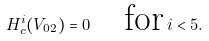Convert formula to latex. <formula><loc_0><loc_0><loc_500><loc_500>H ^ { i } _ { c } ( V _ { 0 2 } ) = 0 \quad \text {for} \, i < 5 .</formula> 